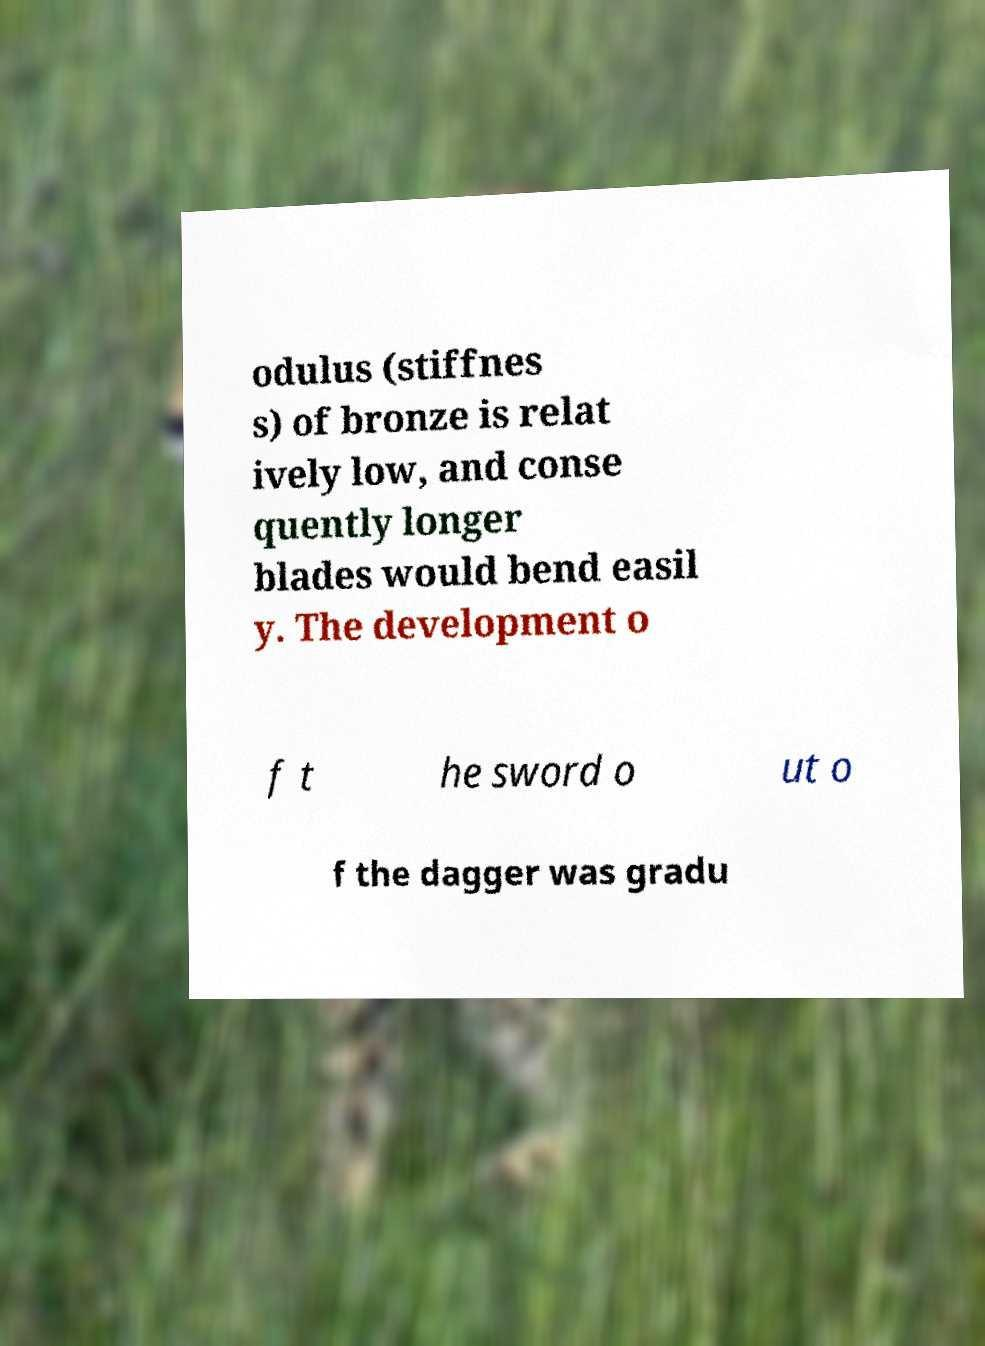Can you accurately transcribe the text from the provided image for me? odulus (stiffnes s) of bronze is relat ively low, and conse quently longer blades would bend easil y. The development o f t he sword o ut o f the dagger was gradu 